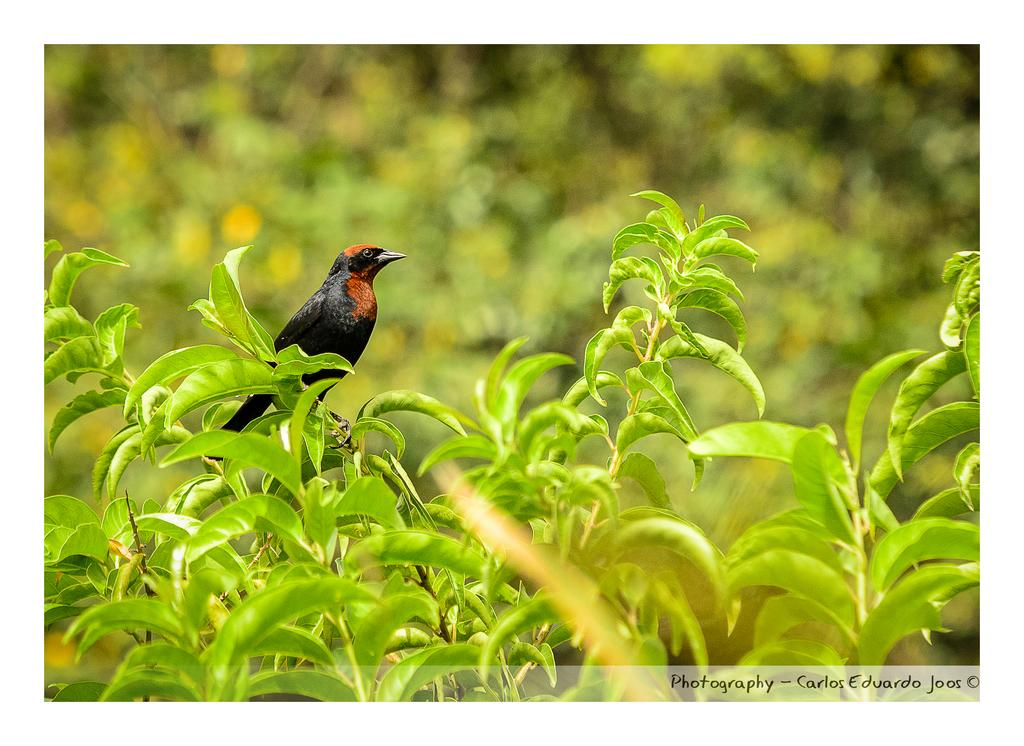What type of animal can be seen in the image? There is a bird on a plant in the image. Can you describe the plant the bird is on? Unfortunately, the facts provided do not give any details about the plant. Is there any text or marking visible in the image? Yes, there is a watermark in the bottom right corner of the image. What type of bomb is the bird holding in the image? There is no bomb present in the image; it features a bird on a plant and a watermark. Can you describe the rifle that the bird is using in the image? There is no rifle present in the image; it features a bird on a plant and a watermark. 